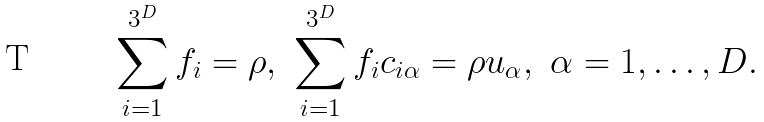<formula> <loc_0><loc_0><loc_500><loc_500>\sum _ { i = 1 } ^ { 3 ^ { D } } f _ { i } = \rho , \ \sum _ { i = 1 } ^ { 3 ^ { D } } f _ { i } c _ { i \alpha } = \rho u _ { \alpha } , \ \alpha = 1 , \dots , D .</formula> 